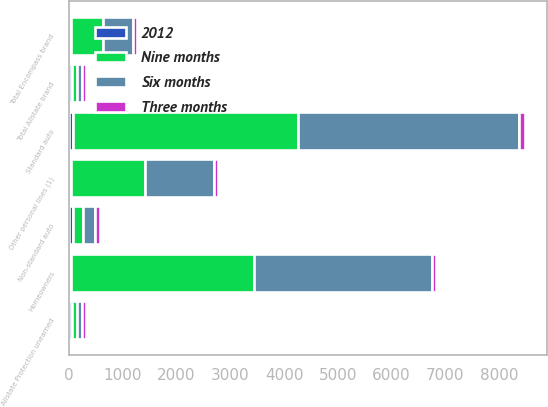<chart> <loc_0><loc_0><loc_500><loc_500><stacked_bar_chart><ecel><fcel>Standard auto<fcel>Non-standard auto<fcel>Homeowners<fcel>Other personal lines (1)<fcel>Total Allstate brand<fcel>Total Encompass brand<fcel>Allstate Protection unearned<nl><fcel>Nine months<fcel>4188<fcel>200<fcel>3396<fcel>1370<fcel>89.05<fcel>593<fcel>89.05<nl><fcel>Six months<fcel>4120<fcel>216<fcel>3314<fcel>1293<fcel>89.05<fcel>560<fcel>89.05<nl><fcel>2012<fcel>71.6<fcel>67.1<fcel>43.5<fcel>39.4<fcel>56.3<fcel>43.4<fcel>56<nl><fcel>Three months<fcel>96.8<fcel>93.6<fcel>75.6<fcel>67.1<fcel>84.5<fcel>75.2<fcel>84.3<nl></chart> 